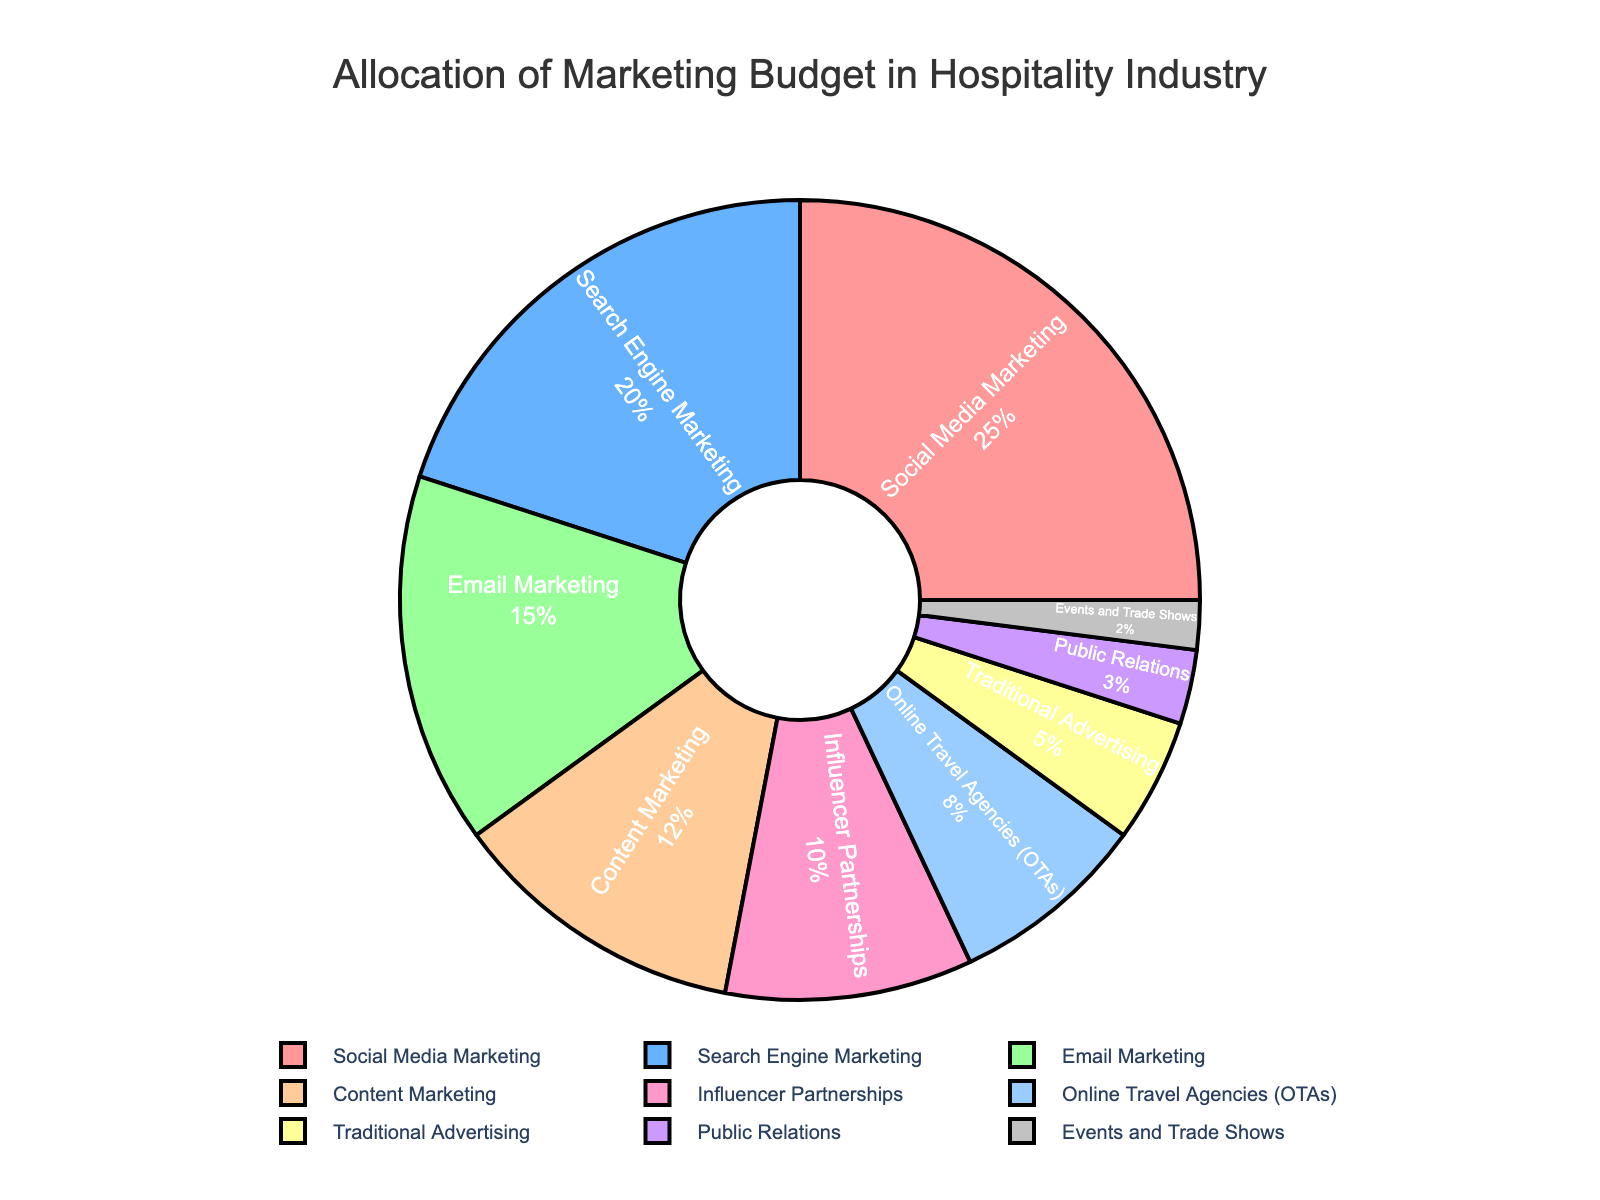What percentage of the budget is allocated to Social Media Marketing and Search Engine Marketing combined? Social Media Marketing is allocated 25% and Search Engine Marketing is allocated 20%. Adding these two percentages gives 25% + 20% = 45%.
Answer: 45% Which channel has the smallest allocation, and what is its percentage? The channel with the smallest allocation is Events and Trade Shows, which is allocated 2% as shown in the figure.
Answer: Events and Trade Shows, 2% How does the percentage allocated to Email Marketing compare to that of Influencer Partnerships? Email Marketing has 15% of the budget allocation, whereas Influencer Partnerships has 10%. Email Marketing is allocated 5% more than Influencer Partnerships.
Answer: Email Marketing is 5% more Is the percentage allocated to Content Marketing greater or less than that allocated to Online Travel Agencies (OTAs)? Content Marketing is allocated 12%, while Online Travel Agencies (OTAs) have an 8% allocation. Thus, Content Marketing has a greater percentage.
Answer: Greater What's the total percentage allocation for channels that have a budget of 10% or less? The channels with 10% or less are Influencer Partnerships (10%), Online Travel Agencies (8%), Traditional Advertising (5%), Public Relations (3%), and Events and Trade Shows (2%). Adding these percentages gives 10% + 8% + 5% + 3% + 2% = 28%.
Answer: 28% What visual feature denotes the markers' boundary between segments? The markers’ boundary between segments is denoted by black lines surrounding each segment.
Answer: Black lines If Public Relations and Traditional Advertising were combined into a single category, what would their combined percentage be? Public Relations has 3% and Traditional Advertising has 5%. Their combined percentage would be 3% + 5% = 8%.
Answer: 8% Which segment is represented in blue color, and what percentage is allocated to it? The blue color represents the Search Engine Marketing segment, which is allocated 20%.
Answer: Search Engine Marketing, 20% Compare the total percentage of Email Marketing and Online Travel Agencies with that of Social Media Marketing. Which total is higher and by how much? Email Marketing has 15% and Online Travel Agencies have 8%, so their total is 15% + 8% = 23%. Social Media Marketing has 25%. Thus, Social Media Marketing has 25% - 23% = 2% more.
Answer: Social Media Marketing is higher by 2% Does the combined percentage of Events and Trade Shows, Public Relations, and Traditional Advertising surpass the percentage allocated to Search Engine Marketing? Events and Trade Shows have 2%, Public Relations have 3%, and Traditional Advertising has 5%. Their combined percentage is 2% + 3% + 5% = 10%. Search Engine Marketing has 20%. Therefore, their combined percentage does not surpass Search Engine Marketing.
Answer: No 